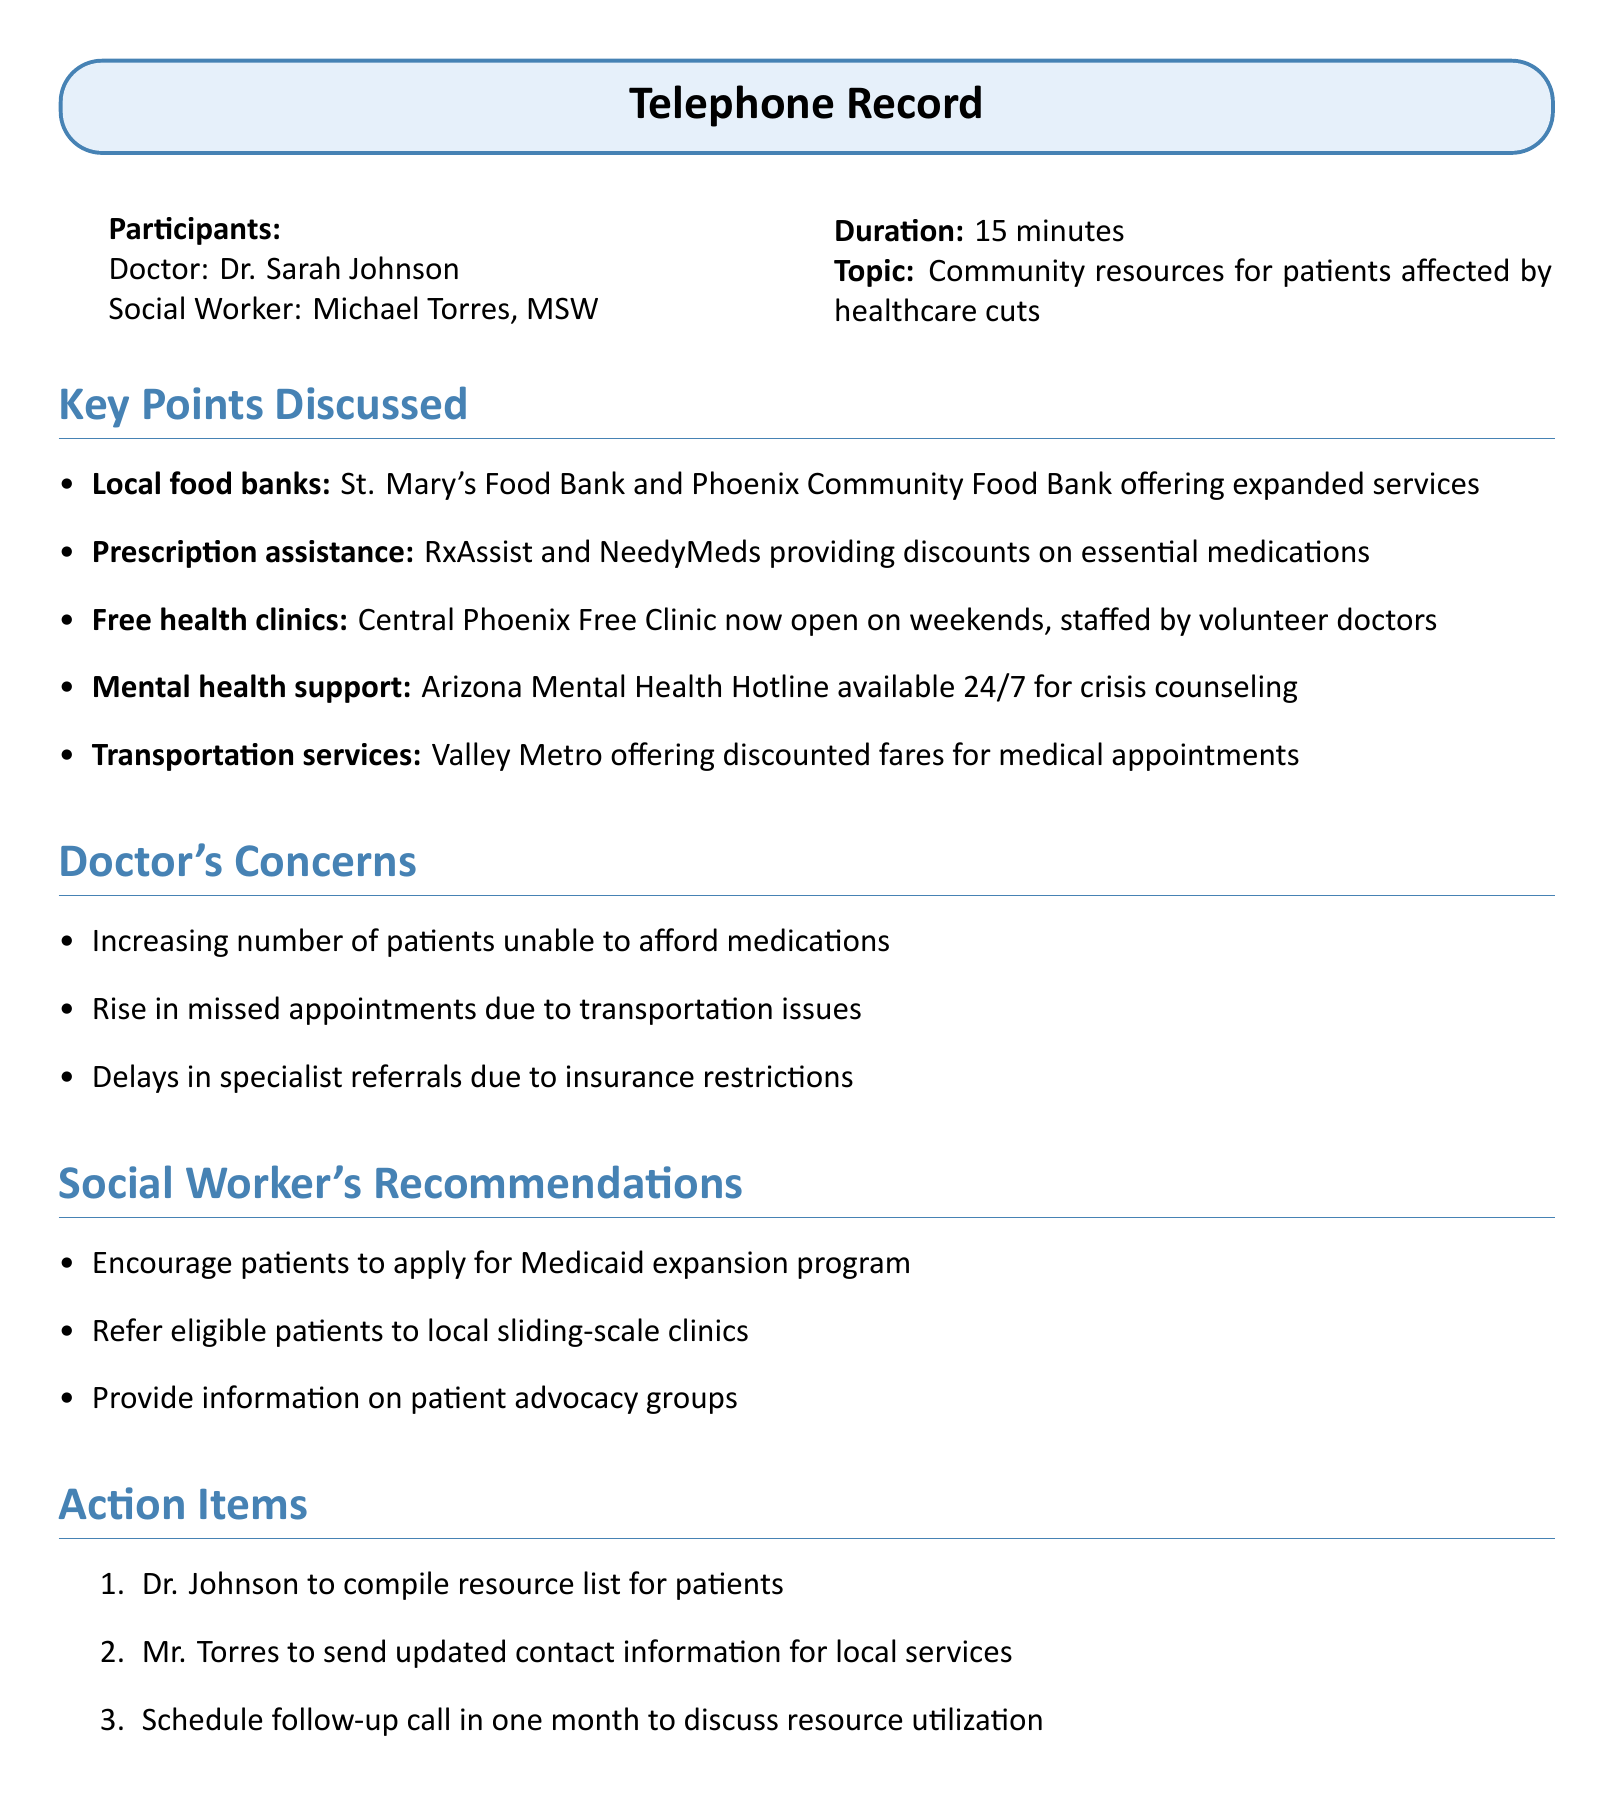What is the name of the doctor? The document specifies that the doctor participating in the call is Dr. Sarah Johnson.
Answer: Dr. Sarah Johnson Who is the social worker? The social worker noted in the document is identified as Michael Torres, MSW.
Answer: Michael Torres, MSW What are the two food banks mentioned? The document lists St. Mary's Food Bank and Phoenix Community Food Bank as local food banks discussed.
Answer: St. Mary's Food Bank and Phoenix Community Food Bank How long was the phone call? The document states that the duration of the discussion was 15 minutes.
Answer: 15 minutes What is one concern the doctor has? The document highlights an increasing number of patients unable to afford medications as one of Dr. Johnson's concerns.
Answer: Increasing number of patients unable to afford medications What is one recommendation given by the social worker? The social worker recommended encouraging patients to apply for the Medicaid expansion program as a way to address healthcare access issues.
Answer: Encourage patients to apply for Medicaid expansion program What type of support is available 24/7? The document indicates that the Arizona Mental Health Hotline is available 24/7 for crisis counseling.
Answer: Arizona Mental Health Hotline What is included in the action items? The action items include Dr. Johnson compiling a resource list for patients as one of the tasks identified in the discussion.
Answer: Dr. Johnson to compile resource list for patients 